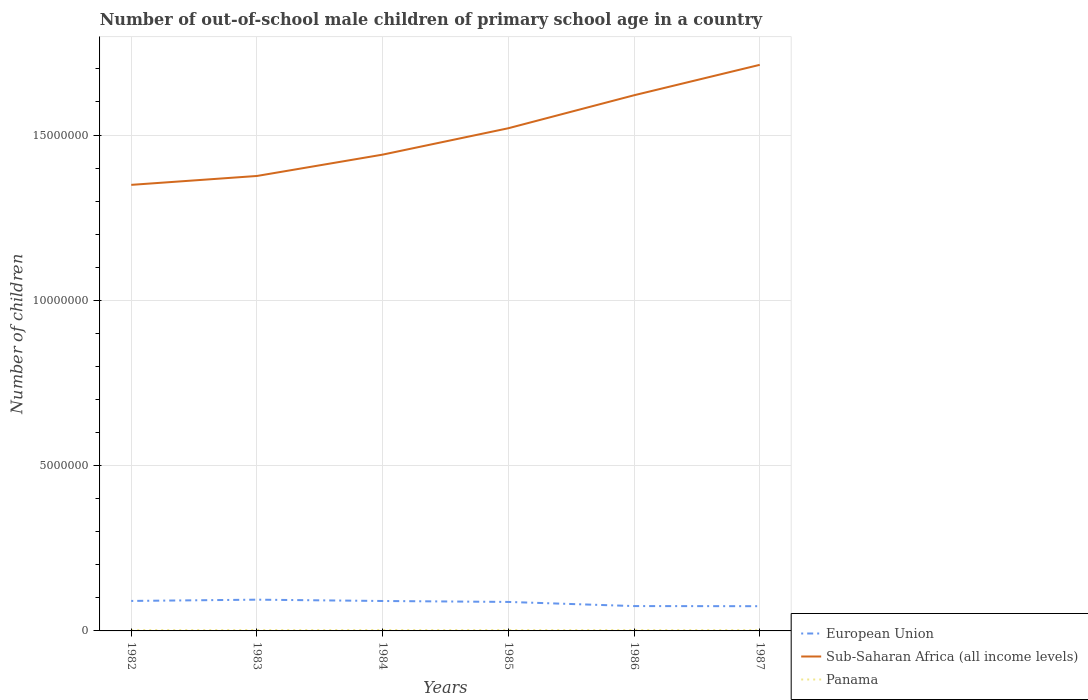Does the line corresponding to Panama intersect with the line corresponding to European Union?
Keep it short and to the point. No. Is the number of lines equal to the number of legend labels?
Your answer should be compact. Yes. Across all years, what is the maximum number of out-of-school male children in Panama?
Your answer should be very brief. 2.49e+04. In which year was the number of out-of-school male children in Sub-Saharan Africa (all income levels) maximum?
Ensure brevity in your answer.  1982. What is the total number of out-of-school male children in Sub-Saharan Africa (all income levels) in the graph?
Make the answer very short. -9.98e+05. What is the difference between the highest and the second highest number of out-of-school male children in Sub-Saharan Africa (all income levels)?
Give a very brief answer. 3.63e+06. What is the difference between the highest and the lowest number of out-of-school male children in European Union?
Offer a terse response. 4. Is the number of out-of-school male children in European Union strictly greater than the number of out-of-school male children in Panama over the years?
Offer a very short reply. No. How many lines are there?
Your answer should be very brief. 3. How many years are there in the graph?
Offer a very short reply. 6. What is the difference between two consecutive major ticks on the Y-axis?
Your response must be concise. 5.00e+06. Are the values on the major ticks of Y-axis written in scientific E-notation?
Keep it short and to the point. No. Does the graph contain grids?
Keep it short and to the point. Yes. Where does the legend appear in the graph?
Your response must be concise. Bottom right. What is the title of the graph?
Your answer should be compact. Number of out-of-school male children of primary school age in a country. What is the label or title of the X-axis?
Give a very brief answer. Years. What is the label or title of the Y-axis?
Make the answer very short. Number of children. What is the Number of children of European Union in 1982?
Provide a short and direct response. 9.07e+05. What is the Number of children in Sub-Saharan Africa (all income levels) in 1982?
Ensure brevity in your answer.  1.35e+07. What is the Number of children in Panama in 1982?
Give a very brief answer. 2.49e+04. What is the Number of children in European Union in 1983?
Provide a short and direct response. 9.45e+05. What is the Number of children in Sub-Saharan Africa (all income levels) in 1983?
Make the answer very short. 1.38e+07. What is the Number of children in Panama in 1983?
Your answer should be compact. 2.69e+04. What is the Number of children of European Union in 1984?
Keep it short and to the point. 9.05e+05. What is the Number of children in Sub-Saharan Africa (all income levels) in 1984?
Ensure brevity in your answer.  1.44e+07. What is the Number of children in Panama in 1984?
Offer a terse response. 2.73e+04. What is the Number of children of European Union in 1985?
Provide a short and direct response. 8.77e+05. What is the Number of children in Sub-Saharan Africa (all income levels) in 1985?
Your answer should be compact. 1.52e+07. What is the Number of children of Panama in 1985?
Offer a very short reply. 2.67e+04. What is the Number of children of European Union in 1986?
Your answer should be very brief. 7.52e+05. What is the Number of children in Sub-Saharan Africa (all income levels) in 1986?
Provide a short and direct response. 1.62e+07. What is the Number of children in Panama in 1986?
Make the answer very short. 2.62e+04. What is the Number of children of European Union in 1987?
Provide a succinct answer. 7.48e+05. What is the Number of children in Sub-Saharan Africa (all income levels) in 1987?
Your response must be concise. 1.71e+07. What is the Number of children of Panama in 1987?
Provide a succinct answer. 2.55e+04. Across all years, what is the maximum Number of children of European Union?
Make the answer very short. 9.45e+05. Across all years, what is the maximum Number of children of Sub-Saharan Africa (all income levels)?
Provide a short and direct response. 1.71e+07. Across all years, what is the maximum Number of children in Panama?
Ensure brevity in your answer.  2.73e+04. Across all years, what is the minimum Number of children of European Union?
Ensure brevity in your answer.  7.48e+05. Across all years, what is the minimum Number of children in Sub-Saharan Africa (all income levels)?
Provide a succinct answer. 1.35e+07. Across all years, what is the minimum Number of children of Panama?
Give a very brief answer. 2.49e+04. What is the total Number of children of European Union in the graph?
Keep it short and to the point. 5.13e+06. What is the total Number of children of Sub-Saharan Africa (all income levels) in the graph?
Your response must be concise. 9.02e+07. What is the total Number of children in Panama in the graph?
Your answer should be compact. 1.57e+05. What is the difference between the Number of children in European Union in 1982 and that in 1983?
Make the answer very short. -3.84e+04. What is the difference between the Number of children of Sub-Saharan Africa (all income levels) in 1982 and that in 1983?
Offer a very short reply. -2.69e+05. What is the difference between the Number of children of Panama in 1982 and that in 1983?
Offer a very short reply. -2012. What is the difference between the Number of children in European Union in 1982 and that in 1984?
Your answer should be compact. 1642. What is the difference between the Number of children of Sub-Saharan Africa (all income levels) in 1982 and that in 1984?
Give a very brief answer. -9.15e+05. What is the difference between the Number of children of Panama in 1982 and that in 1984?
Your answer should be compact. -2428. What is the difference between the Number of children of European Union in 1982 and that in 1985?
Your answer should be compact. 3.00e+04. What is the difference between the Number of children of Sub-Saharan Africa (all income levels) in 1982 and that in 1985?
Offer a very short reply. -1.71e+06. What is the difference between the Number of children of Panama in 1982 and that in 1985?
Keep it short and to the point. -1822. What is the difference between the Number of children of European Union in 1982 and that in 1986?
Provide a short and direct response. 1.55e+05. What is the difference between the Number of children of Sub-Saharan Africa (all income levels) in 1982 and that in 1986?
Your answer should be very brief. -2.71e+06. What is the difference between the Number of children of Panama in 1982 and that in 1986?
Provide a short and direct response. -1287. What is the difference between the Number of children of European Union in 1982 and that in 1987?
Provide a succinct answer. 1.59e+05. What is the difference between the Number of children in Sub-Saharan Africa (all income levels) in 1982 and that in 1987?
Ensure brevity in your answer.  -3.63e+06. What is the difference between the Number of children in Panama in 1982 and that in 1987?
Offer a terse response. -602. What is the difference between the Number of children of European Union in 1983 and that in 1984?
Ensure brevity in your answer.  4.01e+04. What is the difference between the Number of children of Sub-Saharan Africa (all income levels) in 1983 and that in 1984?
Your response must be concise. -6.46e+05. What is the difference between the Number of children of Panama in 1983 and that in 1984?
Give a very brief answer. -416. What is the difference between the Number of children in European Union in 1983 and that in 1985?
Give a very brief answer. 6.84e+04. What is the difference between the Number of children in Sub-Saharan Africa (all income levels) in 1983 and that in 1985?
Your answer should be compact. -1.44e+06. What is the difference between the Number of children of Panama in 1983 and that in 1985?
Make the answer very short. 190. What is the difference between the Number of children of European Union in 1983 and that in 1986?
Keep it short and to the point. 1.94e+05. What is the difference between the Number of children in Sub-Saharan Africa (all income levels) in 1983 and that in 1986?
Ensure brevity in your answer.  -2.44e+06. What is the difference between the Number of children of Panama in 1983 and that in 1986?
Give a very brief answer. 725. What is the difference between the Number of children in European Union in 1983 and that in 1987?
Your response must be concise. 1.97e+05. What is the difference between the Number of children in Sub-Saharan Africa (all income levels) in 1983 and that in 1987?
Offer a terse response. -3.36e+06. What is the difference between the Number of children of Panama in 1983 and that in 1987?
Provide a short and direct response. 1410. What is the difference between the Number of children of European Union in 1984 and that in 1985?
Your answer should be very brief. 2.84e+04. What is the difference between the Number of children of Sub-Saharan Africa (all income levels) in 1984 and that in 1985?
Offer a terse response. -7.98e+05. What is the difference between the Number of children in Panama in 1984 and that in 1985?
Offer a very short reply. 606. What is the difference between the Number of children in European Union in 1984 and that in 1986?
Your response must be concise. 1.54e+05. What is the difference between the Number of children of Sub-Saharan Africa (all income levels) in 1984 and that in 1986?
Make the answer very short. -1.80e+06. What is the difference between the Number of children of Panama in 1984 and that in 1986?
Ensure brevity in your answer.  1141. What is the difference between the Number of children of European Union in 1984 and that in 1987?
Ensure brevity in your answer.  1.57e+05. What is the difference between the Number of children of Sub-Saharan Africa (all income levels) in 1984 and that in 1987?
Make the answer very short. -2.72e+06. What is the difference between the Number of children in Panama in 1984 and that in 1987?
Provide a succinct answer. 1826. What is the difference between the Number of children of European Union in 1985 and that in 1986?
Offer a terse response. 1.25e+05. What is the difference between the Number of children of Sub-Saharan Africa (all income levels) in 1985 and that in 1986?
Offer a very short reply. -9.98e+05. What is the difference between the Number of children of Panama in 1985 and that in 1986?
Make the answer very short. 535. What is the difference between the Number of children in European Union in 1985 and that in 1987?
Give a very brief answer. 1.29e+05. What is the difference between the Number of children in Sub-Saharan Africa (all income levels) in 1985 and that in 1987?
Provide a succinct answer. -1.92e+06. What is the difference between the Number of children in Panama in 1985 and that in 1987?
Give a very brief answer. 1220. What is the difference between the Number of children of European Union in 1986 and that in 1987?
Provide a succinct answer. 3644. What is the difference between the Number of children in Sub-Saharan Africa (all income levels) in 1986 and that in 1987?
Your answer should be very brief. -9.20e+05. What is the difference between the Number of children of Panama in 1986 and that in 1987?
Your response must be concise. 685. What is the difference between the Number of children in European Union in 1982 and the Number of children in Sub-Saharan Africa (all income levels) in 1983?
Offer a terse response. -1.29e+07. What is the difference between the Number of children in European Union in 1982 and the Number of children in Panama in 1983?
Keep it short and to the point. 8.80e+05. What is the difference between the Number of children of Sub-Saharan Africa (all income levels) in 1982 and the Number of children of Panama in 1983?
Keep it short and to the point. 1.35e+07. What is the difference between the Number of children of European Union in 1982 and the Number of children of Sub-Saharan Africa (all income levels) in 1984?
Keep it short and to the point. -1.35e+07. What is the difference between the Number of children in European Union in 1982 and the Number of children in Panama in 1984?
Provide a short and direct response. 8.80e+05. What is the difference between the Number of children of Sub-Saharan Africa (all income levels) in 1982 and the Number of children of Panama in 1984?
Your answer should be very brief. 1.35e+07. What is the difference between the Number of children of European Union in 1982 and the Number of children of Sub-Saharan Africa (all income levels) in 1985?
Provide a short and direct response. -1.43e+07. What is the difference between the Number of children of European Union in 1982 and the Number of children of Panama in 1985?
Offer a very short reply. 8.80e+05. What is the difference between the Number of children of Sub-Saharan Africa (all income levels) in 1982 and the Number of children of Panama in 1985?
Ensure brevity in your answer.  1.35e+07. What is the difference between the Number of children of European Union in 1982 and the Number of children of Sub-Saharan Africa (all income levels) in 1986?
Give a very brief answer. -1.53e+07. What is the difference between the Number of children of European Union in 1982 and the Number of children of Panama in 1986?
Keep it short and to the point. 8.81e+05. What is the difference between the Number of children of Sub-Saharan Africa (all income levels) in 1982 and the Number of children of Panama in 1986?
Give a very brief answer. 1.35e+07. What is the difference between the Number of children of European Union in 1982 and the Number of children of Sub-Saharan Africa (all income levels) in 1987?
Give a very brief answer. -1.62e+07. What is the difference between the Number of children of European Union in 1982 and the Number of children of Panama in 1987?
Your answer should be compact. 8.81e+05. What is the difference between the Number of children in Sub-Saharan Africa (all income levels) in 1982 and the Number of children in Panama in 1987?
Offer a very short reply. 1.35e+07. What is the difference between the Number of children of European Union in 1983 and the Number of children of Sub-Saharan Africa (all income levels) in 1984?
Offer a terse response. -1.35e+07. What is the difference between the Number of children of European Union in 1983 and the Number of children of Panama in 1984?
Provide a short and direct response. 9.18e+05. What is the difference between the Number of children in Sub-Saharan Africa (all income levels) in 1983 and the Number of children in Panama in 1984?
Provide a succinct answer. 1.37e+07. What is the difference between the Number of children of European Union in 1983 and the Number of children of Sub-Saharan Africa (all income levels) in 1985?
Offer a terse response. -1.43e+07. What is the difference between the Number of children in European Union in 1983 and the Number of children in Panama in 1985?
Your answer should be very brief. 9.19e+05. What is the difference between the Number of children in Sub-Saharan Africa (all income levels) in 1983 and the Number of children in Panama in 1985?
Your answer should be very brief. 1.37e+07. What is the difference between the Number of children of European Union in 1983 and the Number of children of Sub-Saharan Africa (all income levels) in 1986?
Your answer should be compact. -1.53e+07. What is the difference between the Number of children of European Union in 1983 and the Number of children of Panama in 1986?
Provide a succinct answer. 9.19e+05. What is the difference between the Number of children in Sub-Saharan Africa (all income levels) in 1983 and the Number of children in Panama in 1986?
Your response must be concise. 1.37e+07. What is the difference between the Number of children of European Union in 1983 and the Number of children of Sub-Saharan Africa (all income levels) in 1987?
Ensure brevity in your answer.  -1.62e+07. What is the difference between the Number of children in European Union in 1983 and the Number of children in Panama in 1987?
Your response must be concise. 9.20e+05. What is the difference between the Number of children in Sub-Saharan Africa (all income levels) in 1983 and the Number of children in Panama in 1987?
Ensure brevity in your answer.  1.37e+07. What is the difference between the Number of children in European Union in 1984 and the Number of children in Sub-Saharan Africa (all income levels) in 1985?
Give a very brief answer. -1.43e+07. What is the difference between the Number of children in European Union in 1984 and the Number of children in Panama in 1985?
Give a very brief answer. 8.79e+05. What is the difference between the Number of children of Sub-Saharan Africa (all income levels) in 1984 and the Number of children of Panama in 1985?
Ensure brevity in your answer.  1.44e+07. What is the difference between the Number of children in European Union in 1984 and the Number of children in Sub-Saharan Africa (all income levels) in 1986?
Offer a very short reply. -1.53e+07. What is the difference between the Number of children of European Union in 1984 and the Number of children of Panama in 1986?
Your answer should be very brief. 8.79e+05. What is the difference between the Number of children in Sub-Saharan Africa (all income levels) in 1984 and the Number of children in Panama in 1986?
Provide a succinct answer. 1.44e+07. What is the difference between the Number of children in European Union in 1984 and the Number of children in Sub-Saharan Africa (all income levels) in 1987?
Offer a terse response. -1.62e+07. What is the difference between the Number of children in European Union in 1984 and the Number of children in Panama in 1987?
Your response must be concise. 8.80e+05. What is the difference between the Number of children in Sub-Saharan Africa (all income levels) in 1984 and the Number of children in Panama in 1987?
Offer a very short reply. 1.44e+07. What is the difference between the Number of children in European Union in 1985 and the Number of children in Sub-Saharan Africa (all income levels) in 1986?
Your answer should be very brief. -1.53e+07. What is the difference between the Number of children in European Union in 1985 and the Number of children in Panama in 1986?
Your answer should be compact. 8.51e+05. What is the difference between the Number of children of Sub-Saharan Africa (all income levels) in 1985 and the Number of children of Panama in 1986?
Offer a terse response. 1.52e+07. What is the difference between the Number of children in European Union in 1985 and the Number of children in Sub-Saharan Africa (all income levels) in 1987?
Your answer should be very brief. -1.62e+07. What is the difference between the Number of children in European Union in 1985 and the Number of children in Panama in 1987?
Provide a succinct answer. 8.51e+05. What is the difference between the Number of children of Sub-Saharan Africa (all income levels) in 1985 and the Number of children of Panama in 1987?
Offer a very short reply. 1.52e+07. What is the difference between the Number of children in European Union in 1986 and the Number of children in Sub-Saharan Africa (all income levels) in 1987?
Provide a short and direct response. -1.64e+07. What is the difference between the Number of children in European Union in 1986 and the Number of children in Panama in 1987?
Offer a very short reply. 7.26e+05. What is the difference between the Number of children of Sub-Saharan Africa (all income levels) in 1986 and the Number of children of Panama in 1987?
Provide a succinct answer. 1.62e+07. What is the average Number of children in European Union per year?
Provide a short and direct response. 8.56e+05. What is the average Number of children of Sub-Saharan Africa (all income levels) per year?
Keep it short and to the point. 1.50e+07. What is the average Number of children of Panama per year?
Offer a very short reply. 2.62e+04. In the year 1982, what is the difference between the Number of children of European Union and Number of children of Sub-Saharan Africa (all income levels)?
Offer a terse response. -1.26e+07. In the year 1982, what is the difference between the Number of children in European Union and Number of children in Panama?
Offer a terse response. 8.82e+05. In the year 1982, what is the difference between the Number of children of Sub-Saharan Africa (all income levels) and Number of children of Panama?
Keep it short and to the point. 1.35e+07. In the year 1983, what is the difference between the Number of children in European Union and Number of children in Sub-Saharan Africa (all income levels)?
Give a very brief answer. -1.28e+07. In the year 1983, what is the difference between the Number of children in European Union and Number of children in Panama?
Provide a short and direct response. 9.18e+05. In the year 1983, what is the difference between the Number of children in Sub-Saharan Africa (all income levels) and Number of children in Panama?
Give a very brief answer. 1.37e+07. In the year 1984, what is the difference between the Number of children of European Union and Number of children of Sub-Saharan Africa (all income levels)?
Ensure brevity in your answer.  -1.35e+07. In the year 1984, what is the difference between the Number of children of European Union and Number of children of Panama?
Your answer should be compact. 8.78e+05. In the year 1984, what is the difference between the Number of children of Sub-Saharan Africa (all income levels) and Number of children of Panama?
Your response must be concise. 1.44e+07. In the year 1985, what is the difference between the Number of children in European Union and Number of children in Sub-Saharan Africa (all income levels)?
Provide a succinct answer. -1.43e+07. In the year 1985, what is the difference between the Number of children in European Union and Number of children in Panama?
Keep it short and to the point. 8.50e+05. In the year 1985, what is the difference between the Number of children of Sub-Saharan Africa (all income levels) and Number of children of Panama?
Make the answer very short. 1.52e+07. In the year 1986, what is the difference between the Number of children in European Union and Number of children in Sub-Saharan Africa (all income levels)?
Ensure brevity in your answer.  -1.55e+07. In the year 1986, what is the difference between the Number of children of European Union and Number of children of Panama?
Keep it short and to the point. 7.25e+05. In the year 1986, what is the difference between the Number of children in Sub-Saharan Africa (all income levels) and Number of children in Panama?
Offer a terse response. 1.62e+07. In the year 1987, what is the difference between the Number of children of European Union and Number of children of Sub-Saharan Africa (all income levels)?
Offer a very short reply. -1.64e+07. In the year 1987, what is the difference between the Number of children of European Union and Number of children of Panama?
Ensure brevity in your answer.  7.22e+05. In the year 1987, what is the difference between the Number of children in Sub-Saharan Africa (all income levels) and Number of children in Panama?
Your response must be concise. 1.71e+07. What is the ratio of the Number of children in European Union in 1982 to that in 1983?
Ensure brevity in your answer.  0.96. What is the ratio of the Number of children of Sub-Saharan Africa (all income levels) in 1982 to that in 1983?
Your answer should be compact. 0.98. What is the ratio of the Number of children in Panama in 1982 to that in 1983?
Give a very brief answer. 0.93. What is the ratio of the Number of children of Sub-Saharan Africa (all income levels) in 1982 to that in 1984?
Your answer should be very brief. 0.94. What is the ratio of the Number of children of Panama in 1982 to that in 1984?
Make the answer very short. 0.91. What is the ratio of the Number of children of European Union in 1982 to that in 1985?
Ensure brevity in your answer.  1.03. What is the ratio of the Number of children in Sub-Saharan Africa (all income levels) in 1982 to that in 1985?
Your answer should be very brief. 0.89. What is the ratio of the Number of children of Panama in 1982 to that in 1985?
Your response must be concise. 0.93. What is the ratio of the Number of children in European Union in 1982 to that in 1986?
Give a very brief answer. 1.21. What is the ratio of the Number of children of Sub-Saharan Africa (all income levels) in 1982 to that in 1986?
Provide a succinct answer. 0.83. What is the ratio of the Number of children of Panama in 1982 to that in 1986?
Make the answer very short. 0.95. What is the ratio of the Number of children of European Union in 1982 to that in 1987?
Offer a terse response. 1.21. What is the ratio of the Number of children of Sub-Saharan Africa (all income levels) in 1982 to that in 1987?
Provide a short and direct response. 0.79. What is the ratio of the Number of children of Panama in 1982 to that in 1987?
Your response must be concise. 0.98. What is the ratio of the Number of children in European Union in 1983 to that in 1984?
Ensure brevity in your answer.  1.04. What is the ratio of the Number of children of Sub-Saharan Africa (all income levels) in 1983 to that in 1984?
Your response must be concise. 0.96. What is the ratio of the Number of children in Panama in 1983 to that in 1984?
Your response must be concise. 0.98. What is the ratio of the Number of children of European Union in 1983 to that in 1985?
Give a very brief answer. 1.08. What is the ratio of the Number of children in Sub-Saharan Africa (all income levels) in 1983 to that in 1985?
Keep it short and to the point. 0.91. What is the ratio of the Number of children of Panama in 1983 to that in 1985?
Your answer should be compact. 1.01. What is the ratio of the Number of children of European Union in 1983 to that in 1986?
Offer a very short reply. 1.26. What is the ratio of the Number of children of Sub-Saharan Africa (all income levels) in 1983 to that in 1986?
Give a very brief answer. 0.85. What is the ratio of the Number of children in Panama in 1983 to that in 1986?
Give a very brief answer. 1.03. What is the ratio of the Number of children of European Union in 1983 to that in 1987?
Give a very brief answer. 1.26. What is the ratio of the Number of children of Sub-Saharan Africa (all income levels) in 1983 to that in 1987?
Provide a succinct answer. 0.8. What is the ratio of the Number of children of Panama in 1983 to that in 1987?
Offer a terse response. 1.06. What is the ratio of the Number of children in European Union in 1984 to that in 1985?
Give a very brief answer. 1.03. What is the ratio of the Number of children of Sub-Saharan Africa (all income levels) in 1984 to that in 1985?
Offer a terse response. 0.95. What is the ratio of the Number of children of Panama in 1984 to that in 1985?
Your answer should be compact. 1.02. What is the ratio of the Number of children of European Union in 1984 to that in 1986?
Your answer should be compact. 1.2. What is the ratio of the Number of children of Sub-Saharan Africa (all income levels) in 1984 to that in 1986?
Your response must be concise. 0.89. What is the ratio of the Number of children of Panama in 1984 to that in 1986?
Provide a short and direct response. 1.04. What is the ratio of the Number of children in European Union in 1984 to that in 1987?
Ensure brevity in your answer.  1.21. What is the ratio of the Number of children in Sub-Saharan Africa (all income levels) in 1984 to that in 1987?
Your answer should be compact. 0.84. What is the ratio of the Number of children in Panama in 1984 to that in 1987?
Make the answer very short. 1.07. What is the ratio of the Number of children in European Union in 1985 to that in 1986?
Keep it short and to the point. 1.17. What is the ratio of the Number of children in Sub-Saharan Africa (all income levels) in 1985 to that in 1986?
Your answer should be very brief. 0.94. What is the ratio of the Number of children of Panama in 1985 to that in 1986?
Your answer should be compact. 1.02. What is the ratio of the Number of children of European Union in 1985 to that in 1987?
Your response must be concise. 1.17. What is the ratio of the Number of children of Sub-Saharan Africa (all income levels) in 1985 to that in 1987?
Keep it short and to the point. 0.89. What is the ratio of the Number of children in Panama in 1985 to that in 1987?
Keep it short and to the point. 1.05. What is the ratio of the Number of children in European Union in 1986 to that in 1987?
Give a very brief answer. 1. What is the ratio of the Number of children of Sub-Saharan Africa (all income levels) in 1986 to that in 1987?
Your answer should be very brief. 0.95. What is the ratio of the Number of children in Panama in 1986 to that in 1987?
Provide a succinct answer. 1.03. What is the difference between the highest and the second highest Number of children of European Union?
Offer a terse response. 3.84e+04. What is the difference between the highest and the second highest Number of children in Sub-Saharan Africa (all income levels)?
Your answer should be compact. 9.20e+05. What is the difference between the highest and the second highest Number of children of Panama?
Provide a short and direct response. 416. What is the difference between the highest and the lowest Number of children of European Union?
Offer a very short reply. 1.97e+05. What is the difference between the highest and the lowest Number of children in Sub-Saharan Africa (all income levels)?
Your answer should be compact. 3.63e+06. What is the difference between the highest and the lowest Number of children of Panama?
Provide a short and direct response. 2428. 